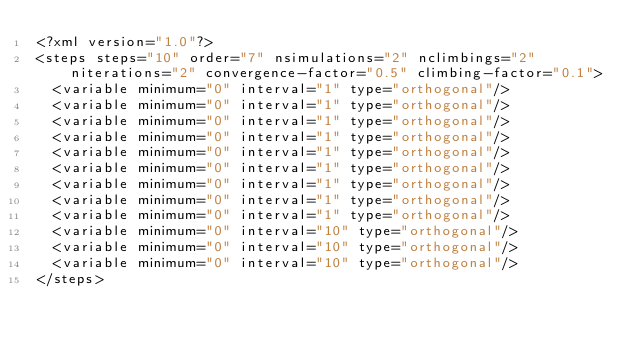Convert code to text. <code><loc_0><loc_0><loc_500><loc_500><_XML_><?xml version="1.0"?>
<steps steps="10" order="7" nsimulations="2" nclimbings="2" niterations="2" convergence-factor="0.5" climbing-factor="0.1">
	<variable minimum="0" interval="1" type="orthogonal"/>
	<variable minimum="0" interval="1" type="orthogonal"/>
	<variable minimum="0" interval="1" type="orthogonal"/>
	<variable minimum="0" interval="1" type="orthogonal"/>
	<variable minimum="0" interval="1" type="orthogonal"/>
	<variable minimum="0" interval="1" type="orthogonal"/>
	<variable minimum="0" interval="1" type="orthogonal"/>
	<variable minimum="0" interval="1" type="orthogonal"/>
	<variable minimum="0" interval="1" type="orthogonal"/>
	<variable minimum="0" interval="10" type="orthogonal"/>
	<variable minimum="0" interval="10" type="orthogonal"/>
	<variable minimum="0" interval="10" type="orthogonal"/>
</steps>
</code> 